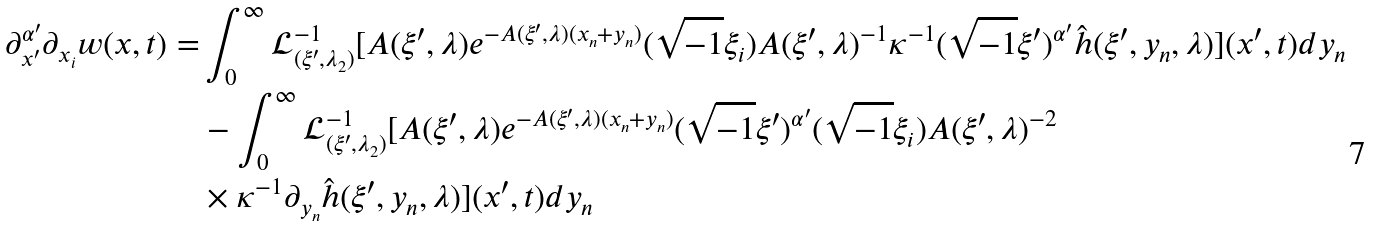<formula> <loc_0><loc_0><loc_500><loc_500>\partial ^ { \alpha ^ { \prime } } _ { x ^ { \prime } } \partial _ { x _ { i } } w ( x , t ) = & \int ^ { \infty } _ { 0 } \mathcal { L } ^ { - 1 } _ { ( \xi ^ { \prime } , \lambda _ { 2 } ) } [ A ( \xi ^ { \prime } , \lambda ) e ^ { - A ( \xi ^ { \prime } , \lambda ) ( x _ { n } + y _ { n } ) } ( \sqrt { - 1 } \xi _ { i } ) A ( \xi ^ { \prime } , \lambda ) ^ { - 1 } \kappa ^ { - 1 } ( \sqrt { - 1 } \xi ^ { \prime } ) ^ { \alpha ^ { \prime } } \hat { h } ( \xi ^ { \prime } , y _ { n } , \lambda ) ] ( x ^ { \prime } , t ) d y _ { n } \\ & - \int ^ { \infty } _ { 0 } \mathcal { L } ^ { - 1 } _ { ( \xi ^ { \prime } , \lambda _ { 2 } ) } [ A ( \xi ^ { \prime } , \lambda ) e ^ { - A ( \xi ^ { \prime } , \lambda ) ( x _ { n } + y _ { n } ) } ( \sqrt { - 1 } \xi ^ { \prime } ) ^ { \alpha ^ { \prime } } ( \sqrt { - 1 } \xi _ { i } ) A ( \xi ^ { \prime } , \lambda ) ^ { - 2 } \\ & \times \kappa ^ { - 1 } \partial _ { y _ { n } } \hat { h } ( \xi ^ { \prime } , y _ { n } , \lambda ) ] ( x ^ { \prime } , t ) d y _ { n }</formula> 